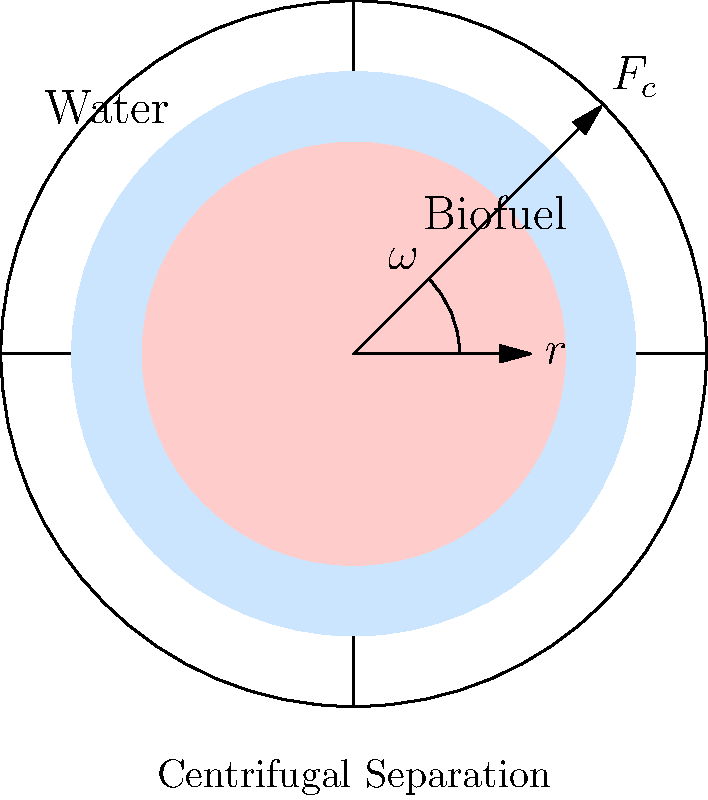In a biofuel separation process, a centrifuge is used to separate biofuel from water. The centrifuge has a radius of 0.5 meters and rotates at 3000 RPM. Calculate the centrifugal force acting on a particle of mass 1.0 × 10⁻⁶ kg at the outer edge of the centrifuge. How does this force compare to the gravitational force on the particle? To solve this problem, we'll follow these steps:

1. Calculate the angular velocity (ω) in rad/s:
   $$\omega = \frac{2\pi \times RPM}{60} = \frac{2\pi \times 3000}{60} = 314.16 \text{ rad/s}$$

2. Use the formula for centrifugal force:
   $$F_c = m\omega^2r$$
   Where:
   $m = 1.0 \times 10^{-6} \text{ kg}$
   $\omega = 314.16 \text{ rad/s}$
   $r = 0.5 \text{ m}$

3. Calculate the centrifugal force:
   $$F_c = (1.0 \times 10^{-6})(314.16)^2(0.5) = 0.0493 \text{ N}$$

4. Calculate the gravitational force on the particle:
   $$F_g = mg = (1.0 \times 10^{-6})(9.81) = 9.81 \times 10^{-6} \text{ N}$$

5. Compare the centrifugal force to the gravitational force:
   $$\frac{F_c}{F_g} = \frac{0.0493}{9.81 \times 10^{-6}} = 5025.5$$

The centrifugal force is about 5026 times stronger than the gravitational force, which explains why centrifugal separation is effective for separating biofuel from water.
Answer: $F_c = 0.0493 \text{ N}$, 5026 times stronger than gravity 